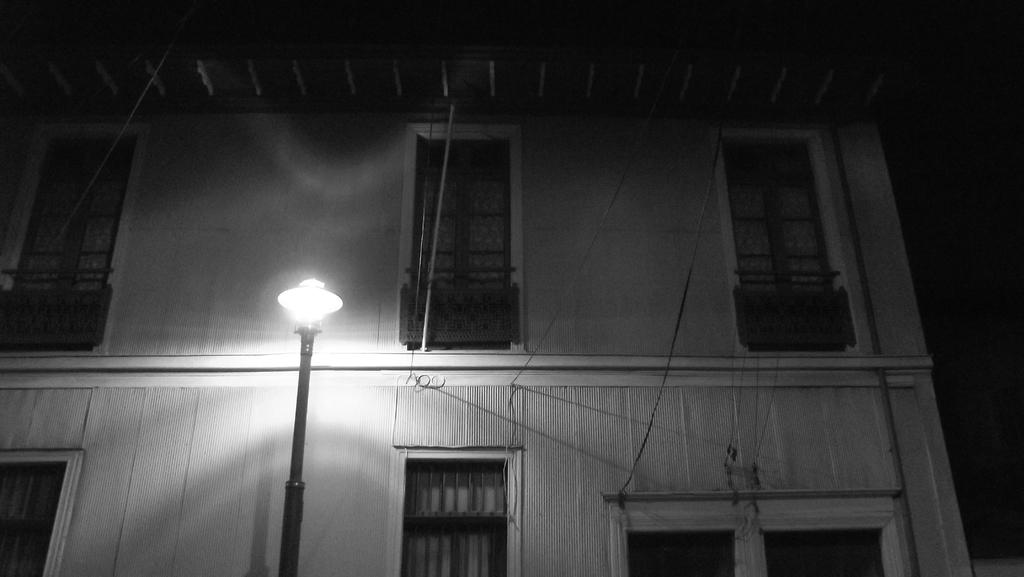What is the main structure in the image? There is a building in the image. What feature can be seen on the building? The building has windows. What other object is present in the image? There is a light pole in the image. How would you describe the overall appearance of the image? The background of the image is dark. What type of coat is hanging on the building in the image? There is no coat present in the image. What part of the building is the home located in the image? The image does not show a home or any specific part of the building. 